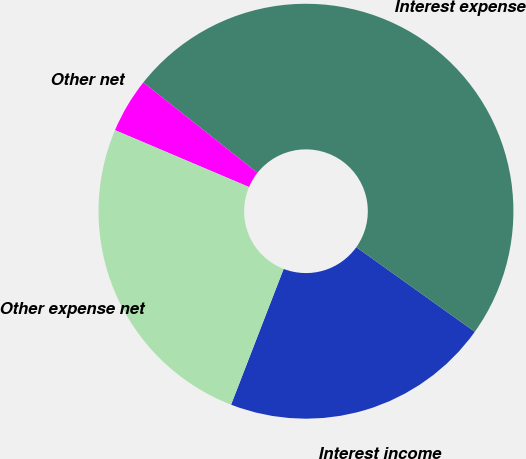Convert chart to OTSL. <chart><loc_0><loc_0><loc_500><loc_500><pie_chart><fcel>Interest income<fcel>Interest expense<fcel>Other net<fcel>Other expense net<nl><fcel>21.01%<fcel>49.21%<fcel>4.27%<fcel>25.51%<nl></chart> 